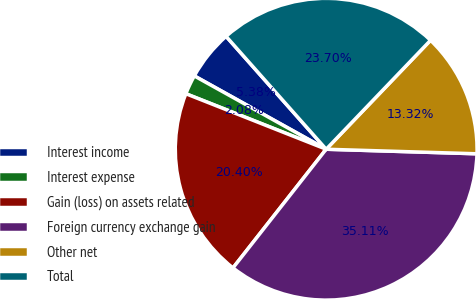<chart> <loc_0><loc_0><loc_500><loc_500><pie_chart><fcel>Interest income<fcel>Interest expense<fcel>Gain (loss) on assets related<fcel>Foreign currency exchange gain<fcel>Other net<fcel>Total<nl><fcel>5.38%<fcel>2.08%<fcel>20.4%<fcel>35.11%<fcel>13.32%<fcel>23.7%<nl></chart> 